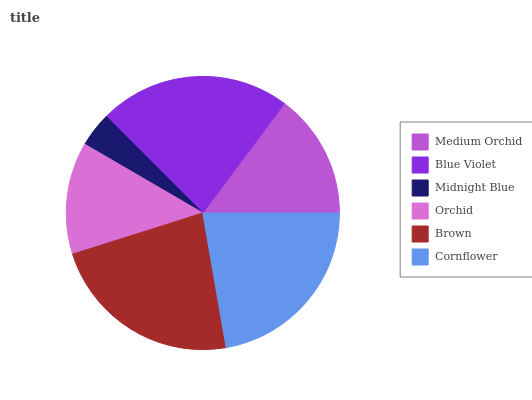Is Midnight Blue the minimum?
Answer yes or no. Yes. Is Brown the maximum?
Answer yes or no. Yes. Is Blue Violet the minimum?
Answer yes or no. No. Is Blue Violet the maximum?
Answer yes or no. No. Is Blue Violet greater than Medium Orchid?
Answer yes or no. Yes. Is Medium Orchid less than Blue Violet?
Answer yes or no. Yes. Is Medium Orchid greater than Blue Violet?
Answer yes or no. No. Is Blue Violet less than Medium Orchid?
Answer yes or no. No. Is Cornflower the high median?
Answer yes or no. Yes. Is Medium Orchid the low median?
Answer yes or no. Yes. Is Orchid the high median?
Answer yes or no. No. Is Blue Violet the low median?
Answer yes or no. No. 